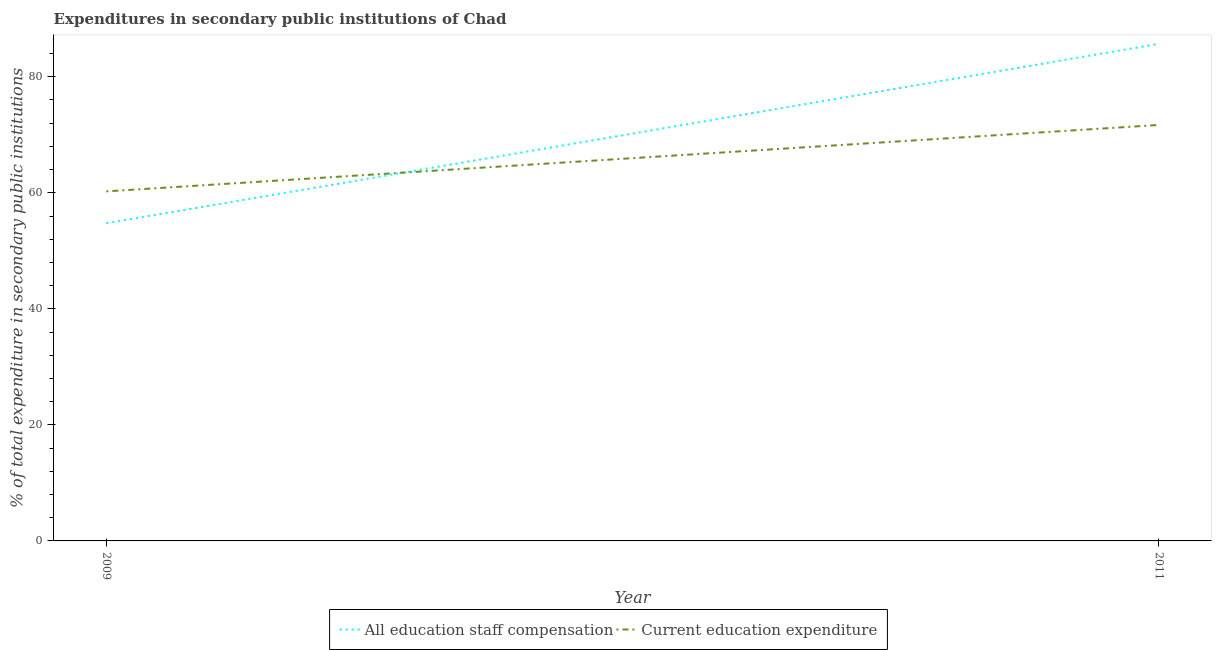How many different coloured lines are there?
Provide a succinct answer. 2. Is the number of lines equal to the number of legend labels?
Keep it short and to the point. Yes. What is the expenditure in education in 2011?
Ensure brevity in your answer.  71.69. Across all years, what is the maximum expenditure in staff compensation?
Give a very brief answer. 85.68. Across all years, what is the minimum expenditure in education?
Keep it short and to the point. 60.25. In which year was the expenditure in education maximum?
Your response must be concise. 2011. What is the total expenditure in staff compensation in the graph?
Offer a very short reply. 140.43. What is the difference between the expenditure in education in 2009 and that in 2011?
Your response must be concise. -11.45. What is the difference between the expenditure in education in 2011 and the expenditure in staff compensation in 2009?
Offer a terse response. 16.94. What is the average expenditure in staff compensation per year?
Offer a terse response. 70.21. In the year 2009, what is the difference between the expenditure in education and expenditure in staff compensation?
Give a very brief answer. 5.5. What is the ratio of the expenditure in staff compensation in 2009 to that in 2011?
Ensure brevity in your answer.  0.64. Is the expenditure in staff compensation in 2009 less than that in 2011?
Your response must be concise. Yes. In how many years, is the expenditure in education greater than the average expenditure in education taken over all years?
Offer a very short reply. 1. Does the expenditure in education monotonically increase over the years?
Give a very brief answer. Yes. How many lines are there?
Provide a succinct answer. 2. How many years are there in the graph?
Offer a very short reply. 2. Are the values on the major ticks of Y-axis written in scientific E-notation?
Ensure brevity in your answer.  No. Does the graph contain grids?
Provide a short and direct response. No. How many legend labels are there?
Provide a succinct answer. 2. How are the legend labels stacked?
Offer a very short reply. Horizontal. What is the title of the graph?
Provide a succinct answer. Expenditures in secondary public institutions of Chad. Does "Non-resident workers" appear as one of the legend labels in the graph?
Make the answer very short. No. What is the label or title of the X-axis?
Your response must be concise. Year. What is the label or title of the Y-axis?
Your response must be concise. % of total expenditure in secondary public institutions. What is the % of total expenditure in secondary public institutions in All education staff compensation in 2009?
Offer a very short reply. 54.75. What is the % of total expenditure in secondary public institutions in Current education expenditure in 2009?
Provide a succinct answer. 60.25. What is the % of total expenditure in secondary public institutions in All education staff compensation in 2011?
Offer a terse response. 85.68. What is the % of total expenditure in secondary public institutions in Current education expenditure in 2011?
Offer a very short reply. 71.69. Across all years, what is the maximum % of total expenditure in secondary public institutions of All education staff compensation?
Keep it short and to the point. 85.68. Across all years, what is the maximum % of total expenditure in secondary public institutions of Current education expenditure?
Your answer should be compact. 71.69. Across all years, what is the minimum % of total expenditure in secondary public institutions of All education staff compensation?
Your answer should be very brief. 54.75. Across all years, what is the minimum % of total expenditure in secondary public institutions in Current education expenditure?
Your answer should be compact. 60.25. What is the total % of total expenditure in secondary public institutions in All education staff compensation in the graph?
Offer a very short reply. 140.43. What is the total % of total expenditure in secondary public institutions of Current education expenditure in the graph?
Provide a short and direct response. 131.94. What is the difference between the % of total expenditure in secondary public institutions in All education staff compensation in 2009 and that in 2011?
Make the answer very short. -30.92. What is the difference between the % of total expenditure in secondary public institutions of Current education expenditure in 2009 and that in 2011?
Offer a very short reply. -11.45. What is the difference between the % of total expenditure in secondary public institutions of All education staff compensation in 2009 and the % of total expenditure in secondary public institutions of Current education expenditure in 2011?
Keep it short and to the point. -16.94. What is the average % of total expenditure in secondary public institutions in All education staff compensation per year?
Offer a terse response. 70.21. What is the average % of total expenditure in secondary public institutions of Current education expenditure per year?
Give a very brief answer. 65.97. In the year 2009, what is the difference between the % of total expenditure in secondary public institutions in All education staff compensation and % of total expenditure in secondary public institutions in Current education expenditure?
Provide a short and direct response. -5.5. In the year 2011, what is the difference between the % of total expenditure in secondary public institutions of All education staff compensation and % of total expenditure in secondary public institutions of Current education expenditure?
Provide a short and direct response. 13.98. What is the ratio of the % of total expenditure in secondary public institutions of All education staff compensation in 2009 to that in 2011?
Your response must be concise. 0.64. What is the ratio of the % of total expenditure in secondary public institutions in Current education expenditure in 2009 to that in 2011?
Your answer should be compact. 0.84. What is the difference between the highest and the second highest % of total expenditure in secondary public institutions in All education staff compensation?
Provide a succinct answer. 30.92. What is the difference between the highest and the second highest % of total expenditure in secondary public institutions in Current education expenditure?
Give a very brief answer. 11.45. What is the difference between the highest and the lowest % of total expenditure in secondary public institutions in All education staff compensation?
Your response must be concise. 30.92. What is the difference between the highest and the lowest % of total expenditure in secondary public institutions in Current education expenditure?
Offer a very short reply. 11.45. 